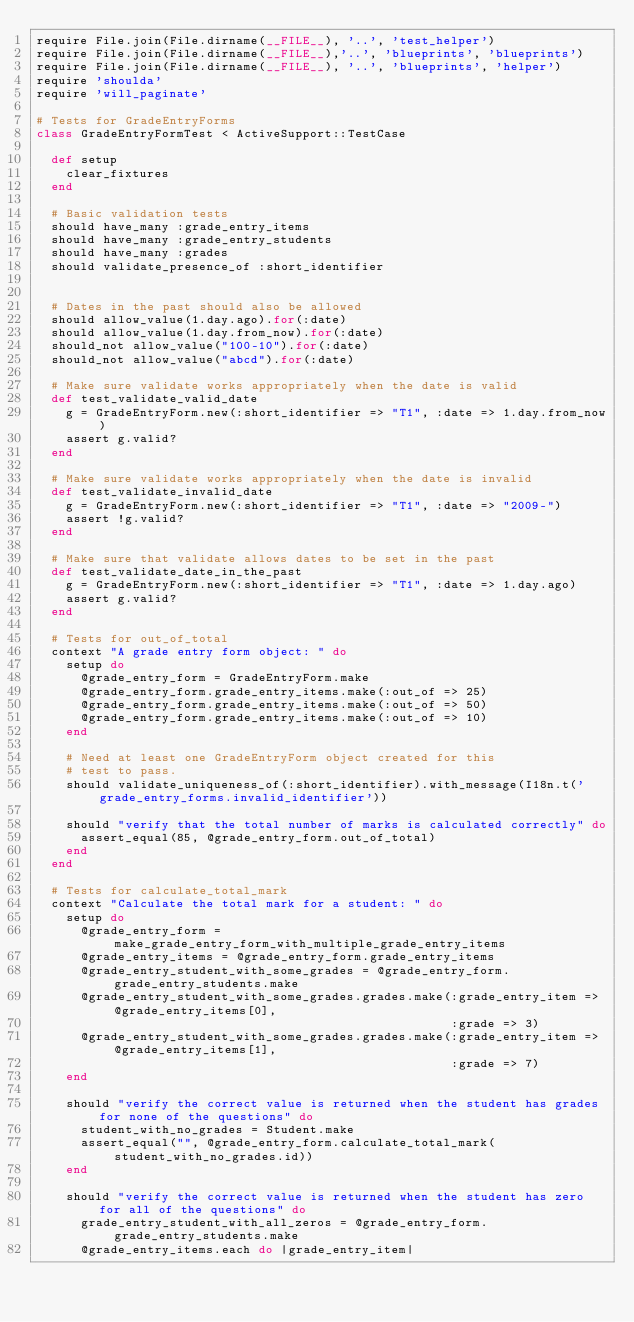Convert code to text. <code><loc_0><loc_0><loc_500><loc_500><_Ruby_>require File.join(File.dirname(__FILE__), '..', 'test_helper')
require File.join(File.dirname(__FILE__),'..', 'blueprints', 'blueprints')
require File.join(File.dirname(__FILE__), '..', 'blueprints', 'helper')
require 'shoulda'
require 'will_paginate'

# Tests for GradeEntryForms
class GradeEntryFormTest < ActiveSupport::TestCase

  def setup
    clear_fixtures
  end

  # Basic validation tests
  should have_many :grade_entry_items
  should have_many :grade_entry_students
  should have_many :grades
  should validate_presence_of :short_identifier


  # Dates in the past should also be allowed
  should allow_value(1.day.ago).for(:date)
  should allow_value(1.day.from_now).for(:date)
  should_not allow_value("100-10").for(:date)
  should_not allow_value("abcd").for(:date)

  # Make sure validate works appropriately when the date is valid
  def test_validate_valid_date
    g = GradeEntryForm.new(:short_identifier => "T1", :date => 1.day.from_now)
    assert g.valid?
  end

  # Make sure validate works appropriately when the date is invalid
  def test_validate_invalid_date
    g = GradeEntryForm.new(:short_identifier => "T1", :date => "2009-")
    assert !g.valid?
  end

  # Make sure that validate allows dates to be set in the past
  def test_validate_date_in_the_past
    g = GradeEntryForm.new(:short_identifier => "T1", :date => 1.day.ago)
    assert g.valid?
  end

  # Tests for out_of_total
  context "A grade entry form object: " do
    setup do
      @grade_entry_form = GradeEntryForm.make
      @grade_entry_form.grade_entry_items.make(:out_of => 25)
      @grade_entry_form.grade_entry_items.make(:out_of => 50)
      @grade_entry_form.grade_entry_items.make(:out_of => 10)
    end

    # Need at least one GradeEntryForm object created for this
    # test to pass.
    should validate_uniqueness_of(:short_identifier).with_message(I18n.t('grade_entry_forms.invalid_identifier'))

    should "verify that the total number of marks is calculated correctly" do
      assert_equal(85, @grade_entry_form.out_of_total)
    end
  end

  # Tests for calculate_total_mark
  context "Calculate the total mark for a student: " do
    setup do
      @grade_entry_form = make_grade_entry_form_with_multiple_grade_entry_items
      @grade_entry_items = @grade_entry_form.grade_entry_items
      @grade_entry_student_with_some_grades = @grade_entry_form.grade_entry_students.make
      @grade_entry_student_with_some_grades.grades.make(:grade_entry_item => @grade_entry_items[0],
                                                        :grade => 3)
      @grade_entry_student_with_some_grades.grades.make(:grade_entry_item => @grade_entry_items[1],
                                                        :grade => 7)
    end

    should "verify the correct value is returned when the student has grades for none of the questions" do
      student_with_no_grades = Student.make
      assert_equal("", @grade_entry_form.calculate_total_mark(student_with_no_grades.id))
    end

    should "verify the correct value is returned when the student has zero for all of the questions" do
      grade_entry_student_with_all_zeros = @grade_entry_form.grade_entry_students.make
      @grade_entry_items.each do |grade_entry_item|</code> 